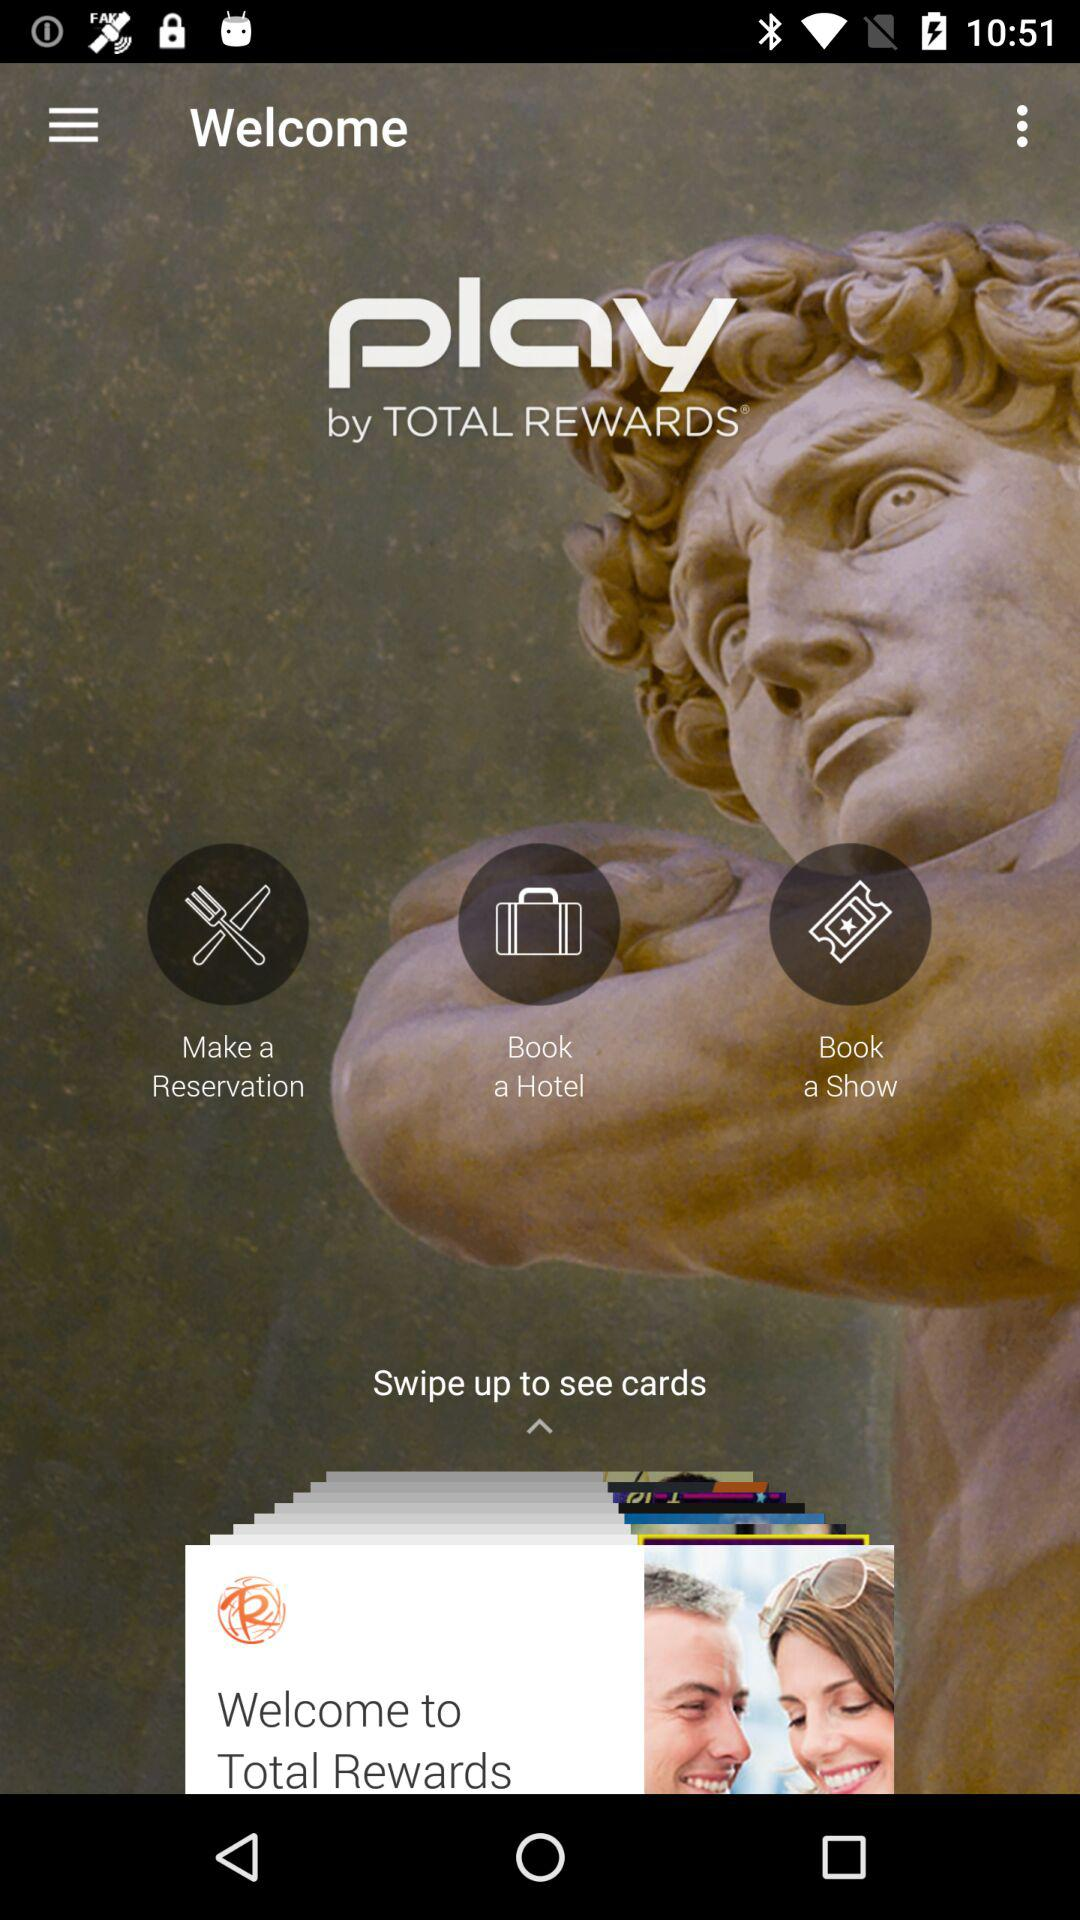What is the application name? The application name is "play". 